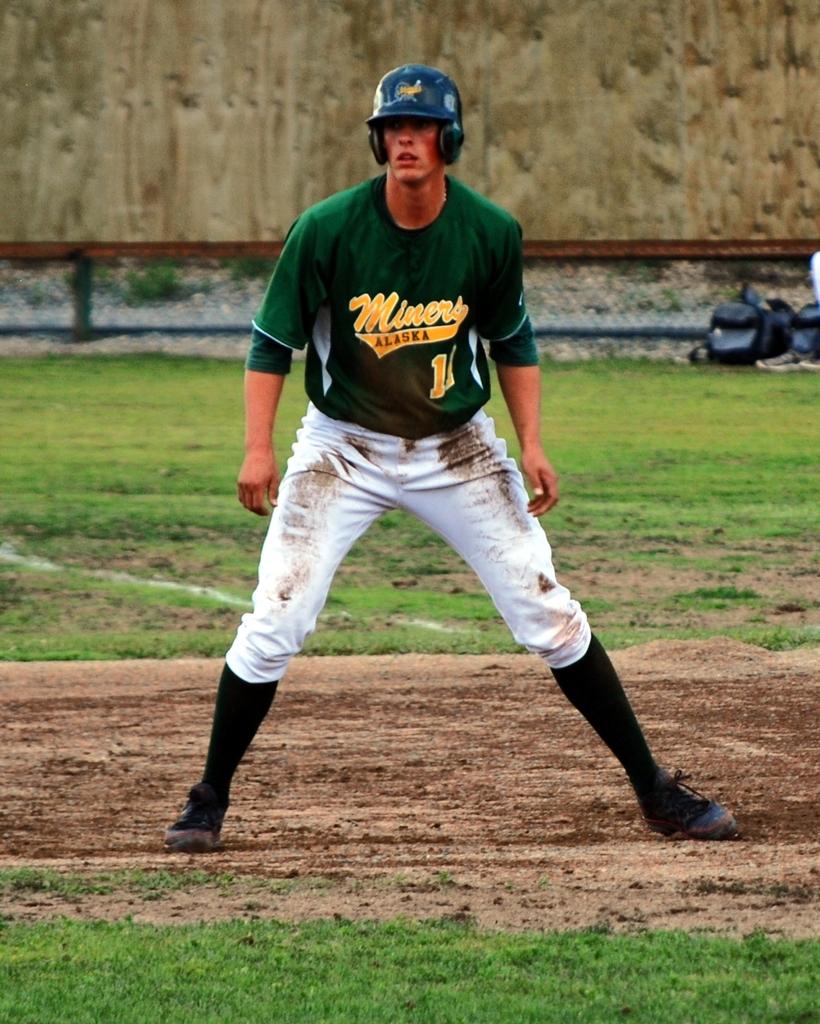Is he on the alaskan team?
Provide a short and direct response. Yes. Which number is on his shirt?
Keep it short and to the point. 11. 